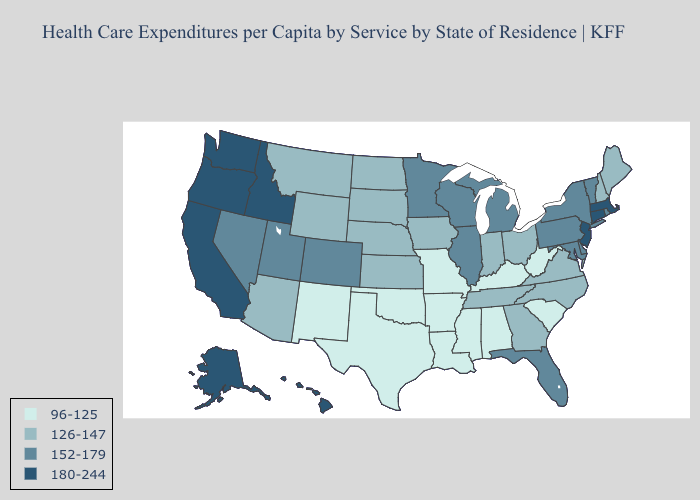Does Nebraska have a lower value than Maryland?
Concise answer only. Yes. Among the states that border Idaho , which have the lowest value?
Write a very short answer. Montana, Wyoming. Does Pennsylvania have the highest value in the USA?
Give a very brief answer. No. Name the states that have a value in the range 152-179?
Keep it brief. Colorado, Delaware, Florida, Illinois, Maryland, Michigan, Minnesota, Nevada, New York, Pennsylvania, Rhode Island, Utah, Vermont, Wisconsin. Is the legend a continuous bar?
Short answer required. No. What is the highest value in the Northeast ?
Quick response, please. 180-244. What is the highest value in states that border Ohio?
Be succinct. 152-179. Does Missouri have the lowest value in the USA?
Give a very brief answer. Yes. Does Alaska have the highest value in the USA?
Short answer required. Yes. What is the lowest value in the USA?
Give a very brief answer. 96-125. Name the states that have a value in the range 126-147?
Keep it brief. Arizona, Georgia, Indiana, Iowa, Kansas, Maine, Montana, Nebraska, New Hampshire, North Carolina, North Dakota, Ohio, South Dakota, Tennessee, Virginia, Wyoming. What is the lowest value in the USA?
Write a very short answer. 96-125. Which states have the highest value in the USA?
Write a very short answer. Alaska, California, Connecticut, Hawaii, Idaho, Massachusetts, New Jersey, Oregon, Washington. Name the states that have a value in the range 96-125?
Quick response, please. Alabama, Arkansas, Kentucky, Louisiana, Mississippi, Missouri, New Mexico, Oklahoma, South Carolina, Texas, West Virginia. 